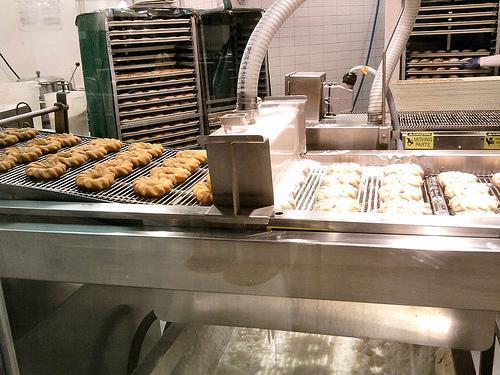How many doughnuts per line?
Give a very brief answer. 4. How many conveyor belts are there?
Give a very brief answer. 1. How many human arms are in the photo?
Give a very brief answer. 1. 